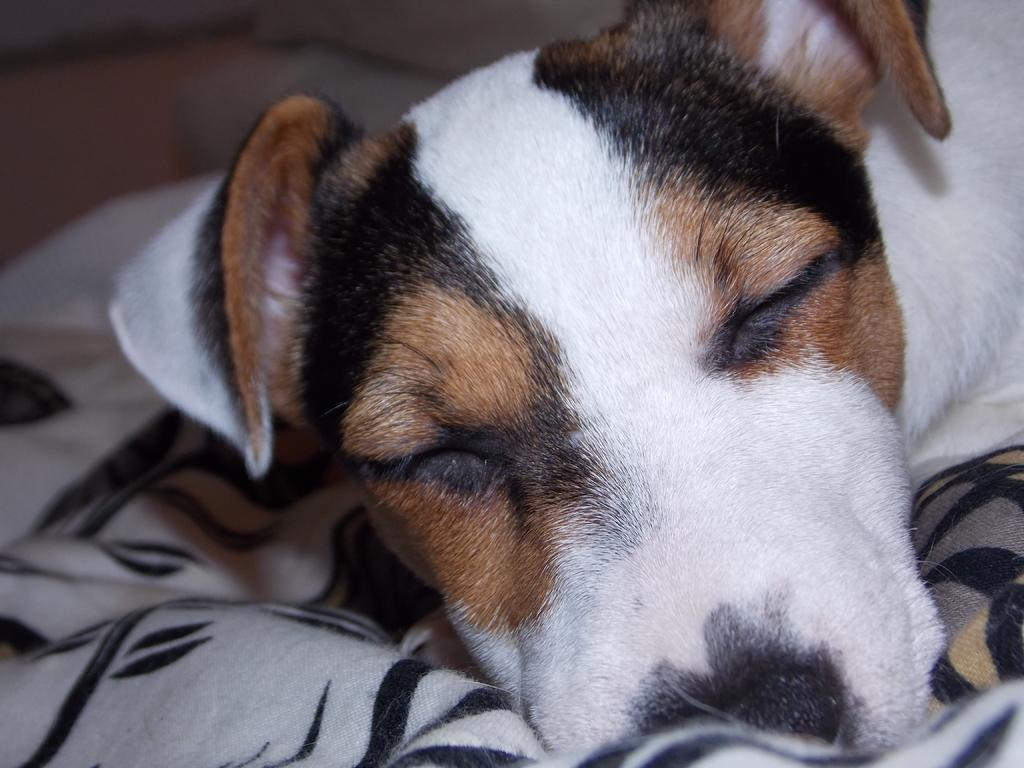What is the main subject of the image? There is a dog in the center of the image. What is the dog doing in the image? The dog is lying down. What can be seen in the background of the image? There is cloth visible in the background of the image. How many sponges are present in the image? There are no sponges visible in the image. What type of cows can be seen grazing in the background of the image? There are no cows present in the image; it only features a dog and cloth in the background. 